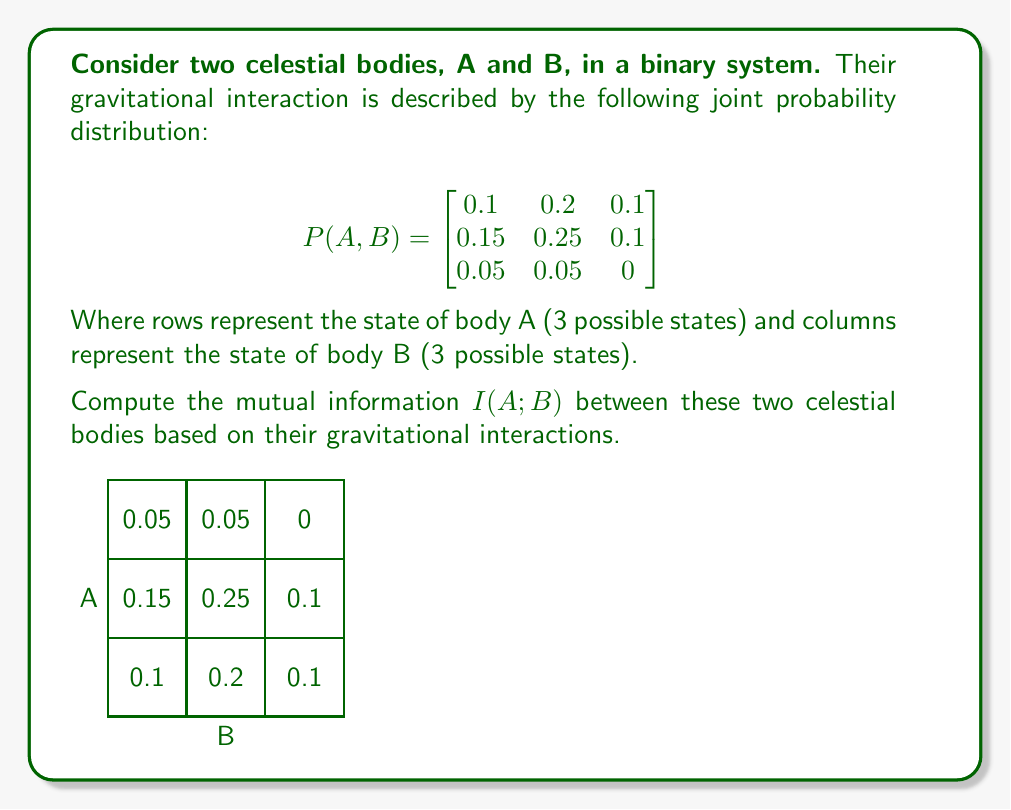Can you solve this math problem? To compute the mutual information $I(A;B)$, we'll follow these steps:

1) Calculate marginal probabilities $P(A)$ and $P(B)$:

   $P(A_1) = 0.1 + 0.2 + 0.1 = 0.4$
   $P(A_2) = 0.15 + 0.25 + 0.1 = 0.5$
   $P(A_3) = 0.05 + 0.05 + 0 = 0.1$

   $P(B_1) = 0.1 + 0.15 + 0.05 = 0.3$
   $P(B_2) = 0.2 + 0.25 + 0.05 = 0.5$
   $P(B_3) = 0.1 + 0.1 + 0 = 0.2$

2) Calculate entropy of A, $H(A)$:
   $$H(A) = -\sum_{i=1}^3 P(A_i) \log_2 P(A_i)$$
   $$H(A) = -[0.4 \log_2 0.4 + 0.5 \log_2 0.5 + 0.1 \log_2 0.1] \approx 1.3610$$

3) Calculate entropy of B, $H(B)$:
   $$H(B) = -\sum_{j=1}^3 P(B_j) \log_2 P(B_j)$$
   $$H(B) = -[0.3 \log_2 0.3 + 0.5 \log_2 0.5 + 0.2 \log_2 0.2] \approx 1.4855$$

4) Calculate joint entropy $H(A,B)$:
   $$H(A,B) = -\sum_{i=1}^3 \sum_{j=1}^3 P(A_i,B_j) \log_2 P(A_i,B_j)$$
   $$H(A,B) = -[0.1 \log_2 0.1 + 0.2 \log_2 0.2 + ... + 0 \log_2 0] \approx 2.6723$$

5) Calculate mutual information:
   $$I(A;B) = H(A) + H(B) - H(A,B)$$
   $$I(A;B) = 1.3610 + 1.4855 - 2.6723 \approx 0.1742$$

Therefore, the mutual information between the two celestial bodies is approximately 0.1742 bits.
Answer: $I(A;B) \approx 0.1742$ bits 